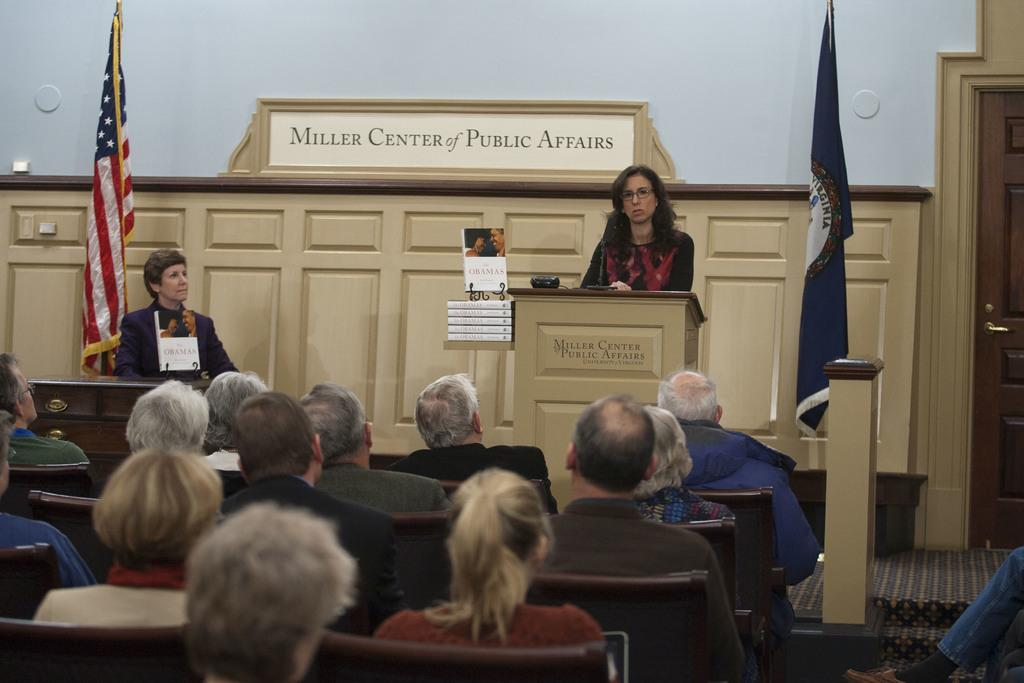What is the color of the wall in the image? The wall in the image is white. What can be seen hanging on the wall? There are flags in the image. What type of furniture is present in the image? There are chairs and cupboards in the image. What is a feature of the room that allows access to other areas? There is a door in the image. Who is present in the image? There is a group of people in the image. What type of drum is being played by the grandfather in the image? There is no grandfather or drum present in the image. 